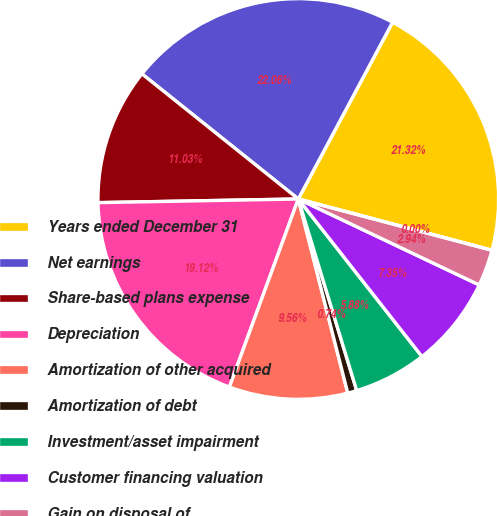Convert chart to OTSL. <chart><loc_0><loc_0><loc_500><loc_500><pie_chart><fcel>Years ended December 31<fcel>Net earnings<fcel>Share-based plans expense<fcel>Depreciation<fcel>Amortization of other acquired<fcel>Amortization of debt<fcel>Investment/asset impairment<fcel>Customer financing valuation<fcel>Gain on disposal of<fcel>Gain on dispositions/business<nl><fcel>21.32%<fcel>22.06%<fcel>11.03%<fcel>19.12%<fcel>9.56%<fcel>0.74%<fcel>5.88%<fcel>7.35%<fcel>2.94%<fcel>0.0%<nl></chart> 